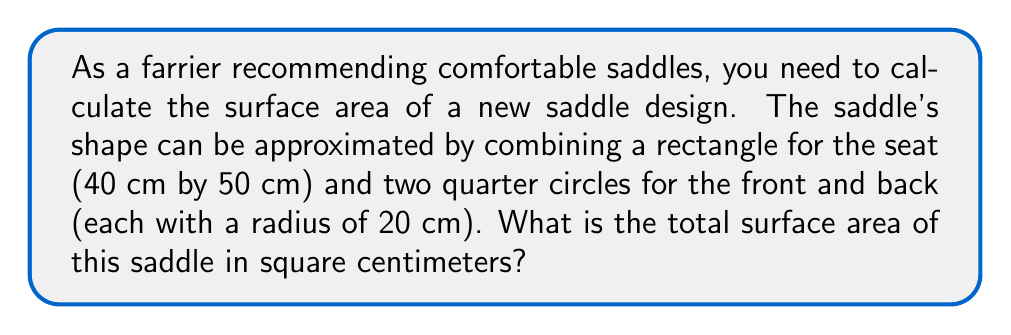Give your solution to this math problem. To calculate the total surface area of the saddle, we need to add the areas of the rectangular seat and the two quarter circles.

1. Area of the rectangular seat:
   $$ A_{rectangle} = l \times w = 40 \text{ cm} \times 50 \text{ cm} = 2000 \text{ cm}^2 $$

2. Area of one quarter circle:
   $$ A_{quarter} = \frac{1}{4} \pi r^2 = \frac{1}{4} \pi (20 \text{ cm})^2 = 100\pi \text{ cm}^2 $$

3. Total area of two quarter circles:
   $$ A_{two quarters} = 2 \times 100\pi \text{ cm}^2 = 200\pi \text{ cm}^2 $$

4. Total surface area of the saddle:
   $$ A_{total} = A_{rectangle} + A_{two quarters} $$
   $$ A_{total} = 2000 \text{ cm}^2 + 200\pi \text{ cm}^2 $$
   $$ A_{total} = 2000 + 200\pi \text{ cm}^2 $$
   $$ A_{total} \approx 2628.32 \text{ cm}^2 $$

[asy]
import geometry;

size(200);

// Draw rectangle
draw((0,0)--(50,0)--(50,40)--(0,40)--cycle);

// Draw quarter circles
path p1 = arc((0,0),20,0,90);
path p2 = arc((50,0),20,90,180);
draw(p1);
draw(p2);

// Labels
label("50 cm", (25,0), S);
label("40 cm", (50,20), E);
label("r = 20 cm", (10,10), NW);
[/asy]
Answer: $2000 + 200\pi \text{ cm}^2 \approx 2628.32 \text{ cm}^2$ 